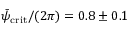Convert formula to latex. <formula><loc_0><loc_0><loc_500><loc_500>\bar { \psi } _ { c r i t } / ( 2 \pi ) = 0 . 8 \pm 0 . 1</formula> 